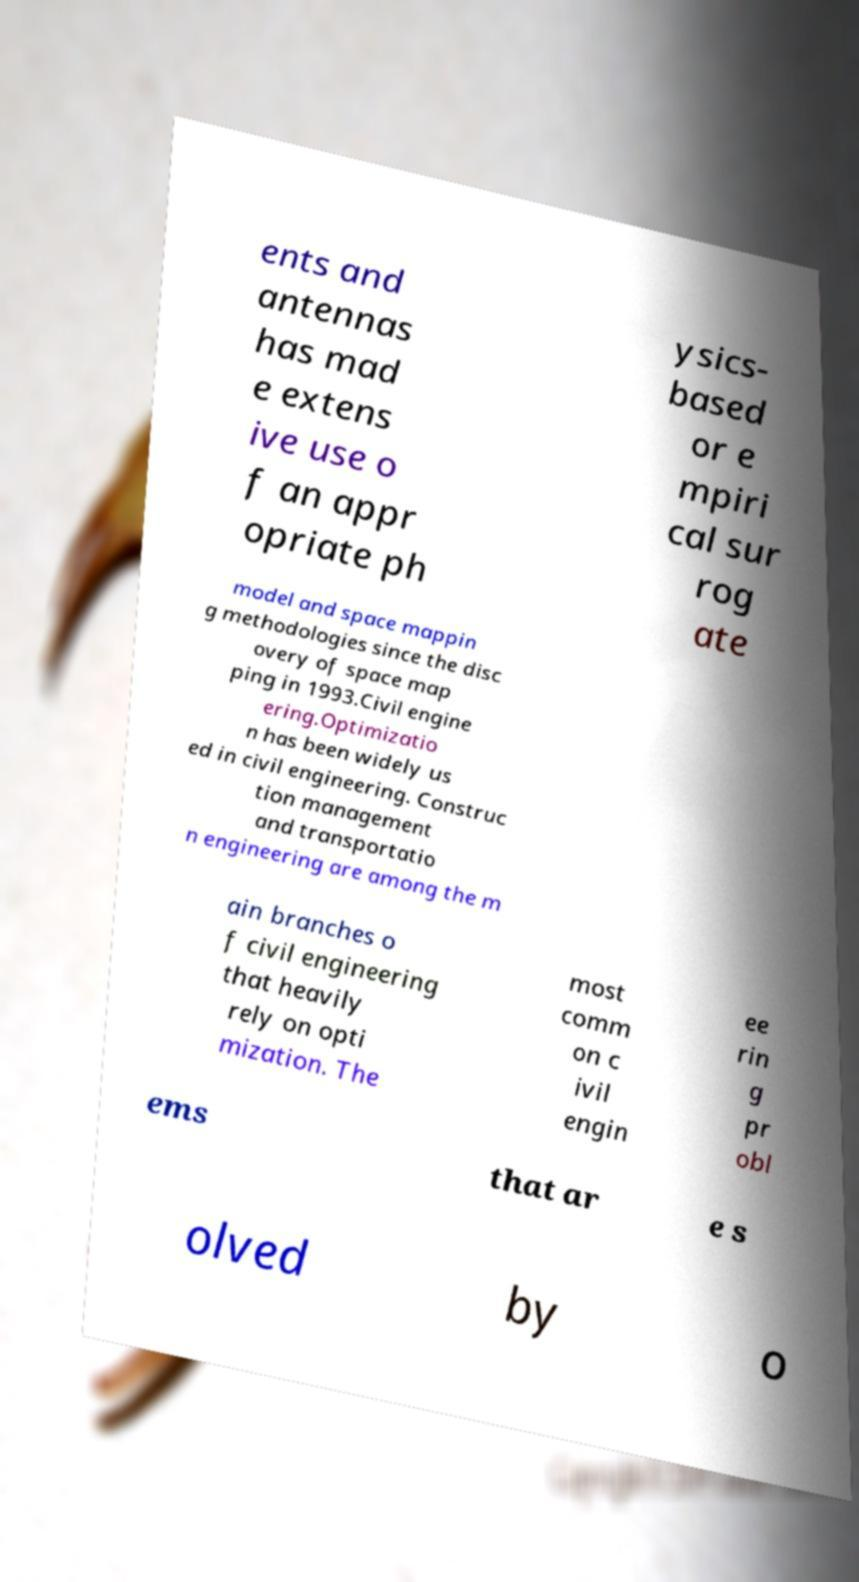Can you accurately transcribe the text from the provided image for me? ents and antennas has mad e extens ive use o f an appr opriate ph ysics- based or e mpiri cal sur rog ate model and space mappin g methodologies since the disc overy of space map ping in 1993.Civil engine ering.Optimizatio n has been widely us ed in civil engineering. Construc tion management and transportatio n engineering are among the m ain branches o f civil engineering that heavily rely on opti mization. The most comm on c ivil engin ee rin g pr obl ems that ar e s olved by o 